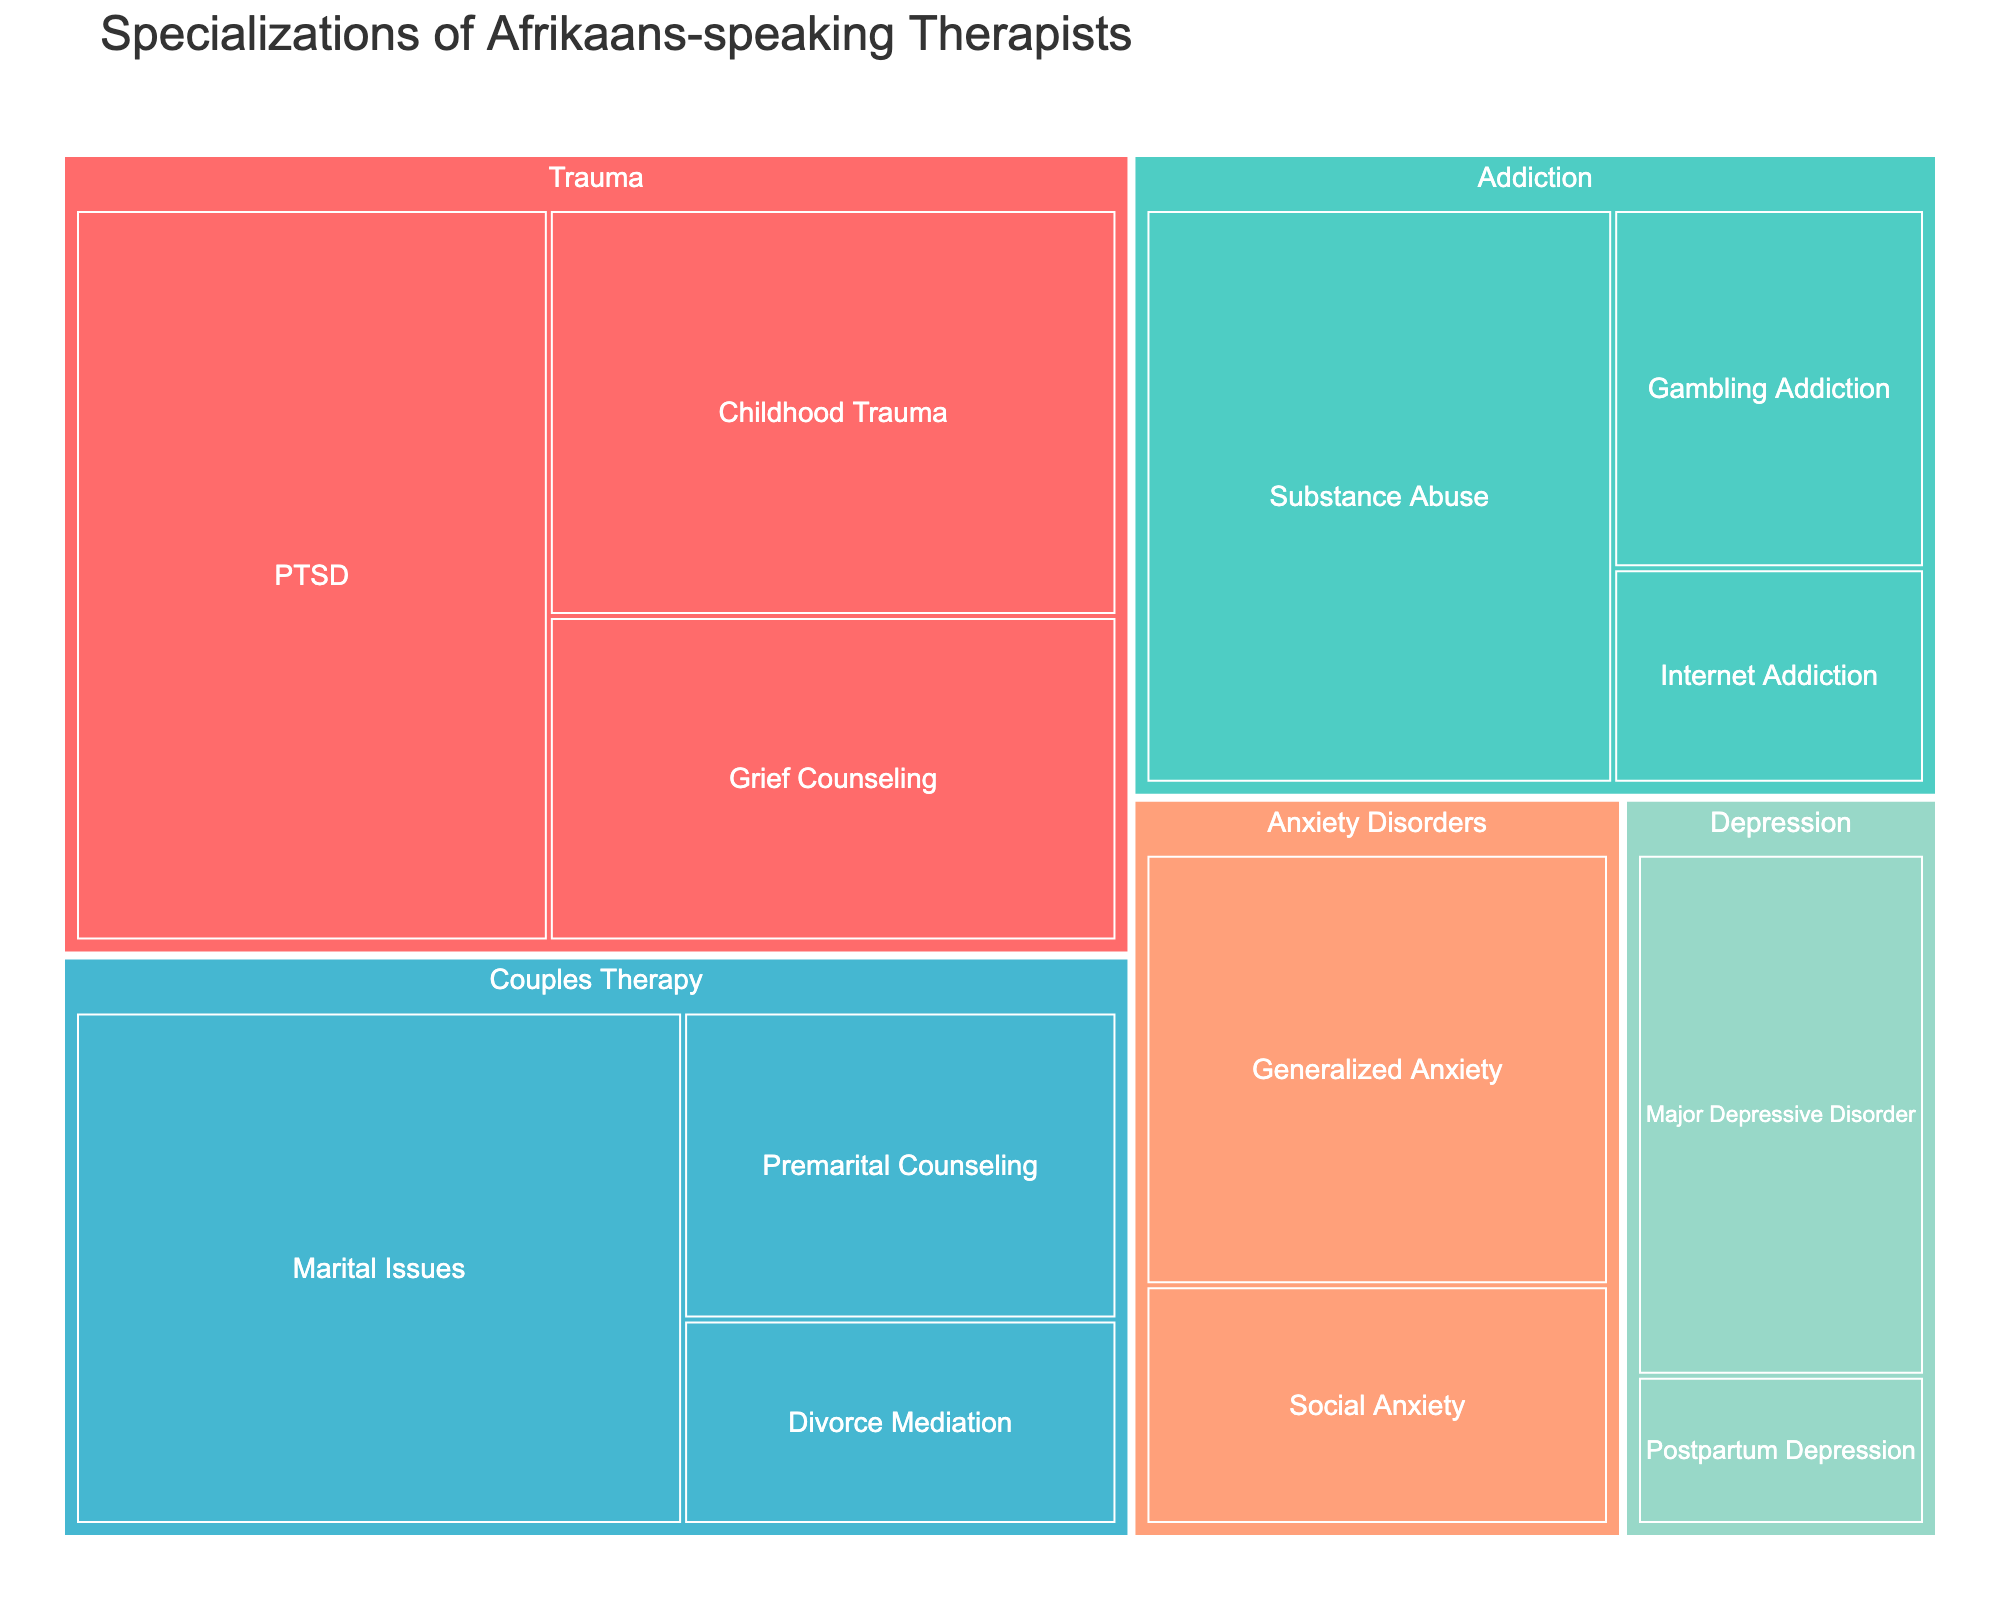What is the title of the Treemap figure? The title of the Treemap is usually displayed prominently at the top center of the figure, indicating the main topic or focus of the visual representation.
Answer: Specializations of Afrikaans-speaking Therapists Which specialization has the highest percentage? The largest section or the one with the largest area in the Treemap usually represents the specialization with the highest percentage.
Answer: PTSD What is the total percentage for all Couples Therapy specializations? To find this, sum the percentages of all specializations under the Couples Therapy category (Marital Issues, Premarital Counseling, Divorce Mediation).
Answer: 24% How does the percentage of Substance Abuse compare to that of Major Depressive Disorder? Compare the percentages by looking at their respective areas or values labeled in the Treemap. Substance Abuse is 12% and Major Depressive Disorder is 7%.
Answer: Substance Abuse is higher by 5% Which category has the second highest total percentage? Sum the percentages of each category individually and compare them to find the second highest total percentage. Trauma has 33%, Addiction has 20%, Couples Therapy has 24%, Anxiety Disorders have 14%, Depression has 9%.
Answer: Couples Therapy What is the smallest specialization percentage indicated in the Treemap? Look for the smallest section of the Treemap by area or percentage label.
Answer: Postpartum Depression Is there a category where all specializations have a percentage less than 10%? Check each specialization within its category to see if all of them have a value below 10%.
Answer: Yes, Anxiety Disorders How many specializations are there in total? Count the total number of boxes (specializations) represented in the Treemap.
Answer: 13 What percentage of Afrikaans-speaking therapists specialize in any form of trauma therapy? Sum the percentages of all trauma-related specializations (PTSD, Childhood Trauma, Grief Counseling).
Answer: 33% How does the sum of the percentages for Anxiety Disorders compare to the sum of the percentages for Depression? Calculate the sum for each category individually and compare the totals. Anxiety Disorders sum is 14%, Depression sum is 9%.
Answer: Anxiety Disorders sum is higher by 5% 